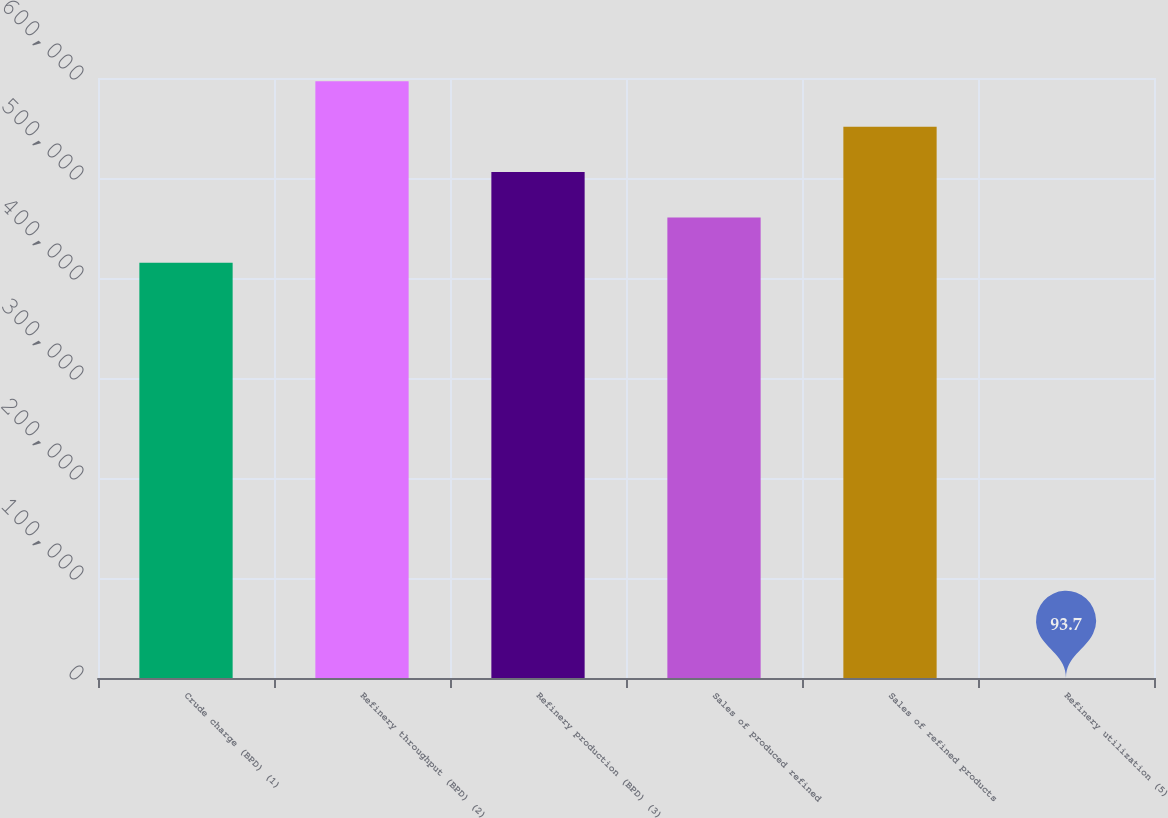Convert chart. <chart><loc_0><loc_0><loc_500><loc_500><bar_chart><fcel>Crude charge (BPD) (1)<fcel>Refinery throughput (BPD) (2)<fcel>Refinery production (BPD) (3)<fcel>Sales of produced refined<fcel>Sales of refined products<fcel>Refinery utilization (5)<nl><fcel>415210<fcel>596669<fcel>505939<fcel>460575<fcel>551304<fcel>93.7<nl></chart> 